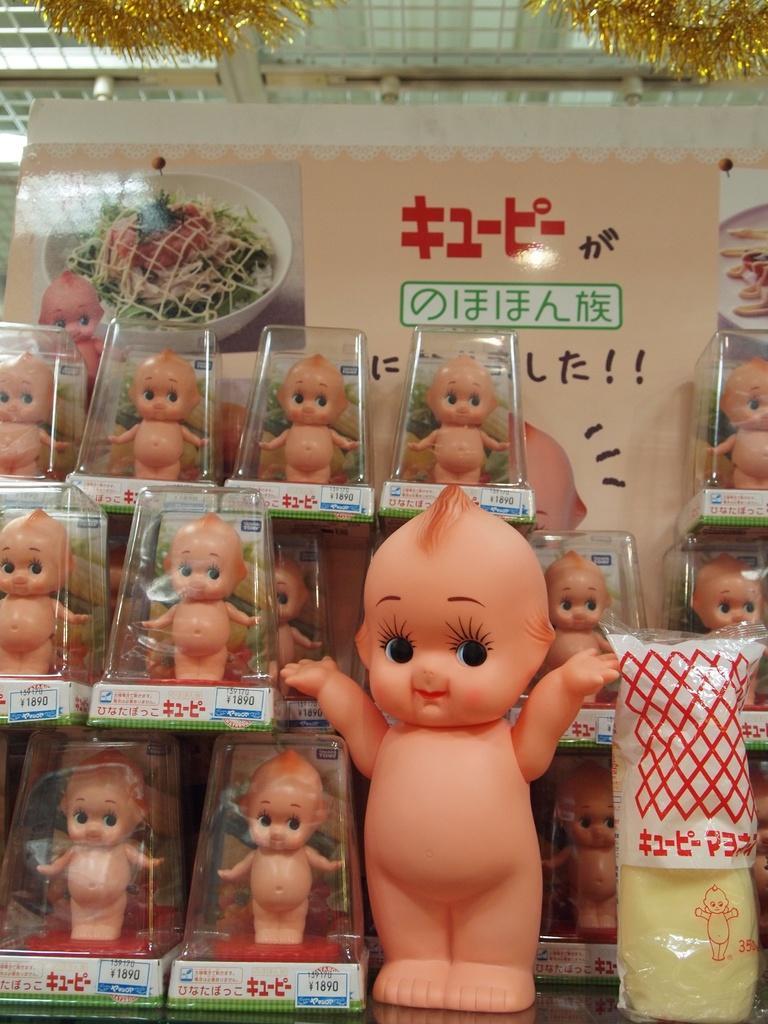In one or two sentences, can you explain what this image depicts? In the image in the center, we can see plastic packets. In the plastic packets, we can see baby toys. In the background there is a wall, banner and some decorative items. 